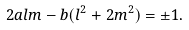Convert formula to latex. <formula><loc_0><loc_0><loc_500><loc_500>2 a l m - b ( l ^ { 2 } + 2 m ^ { 2 } ) = \pm 1 .</formula> 